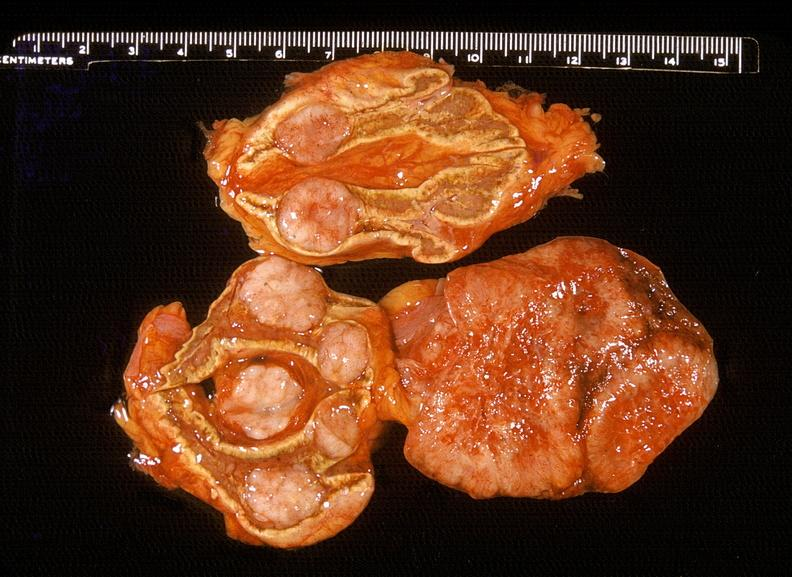what is present?
Answer the question using a single word or phrase. Endocrine 